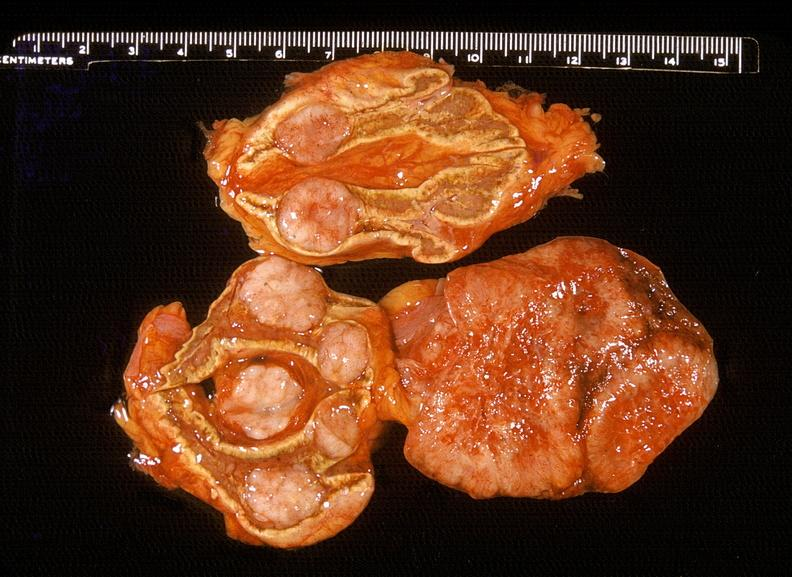what is present?
Answer the question using a single word or phrase. Endocrine 